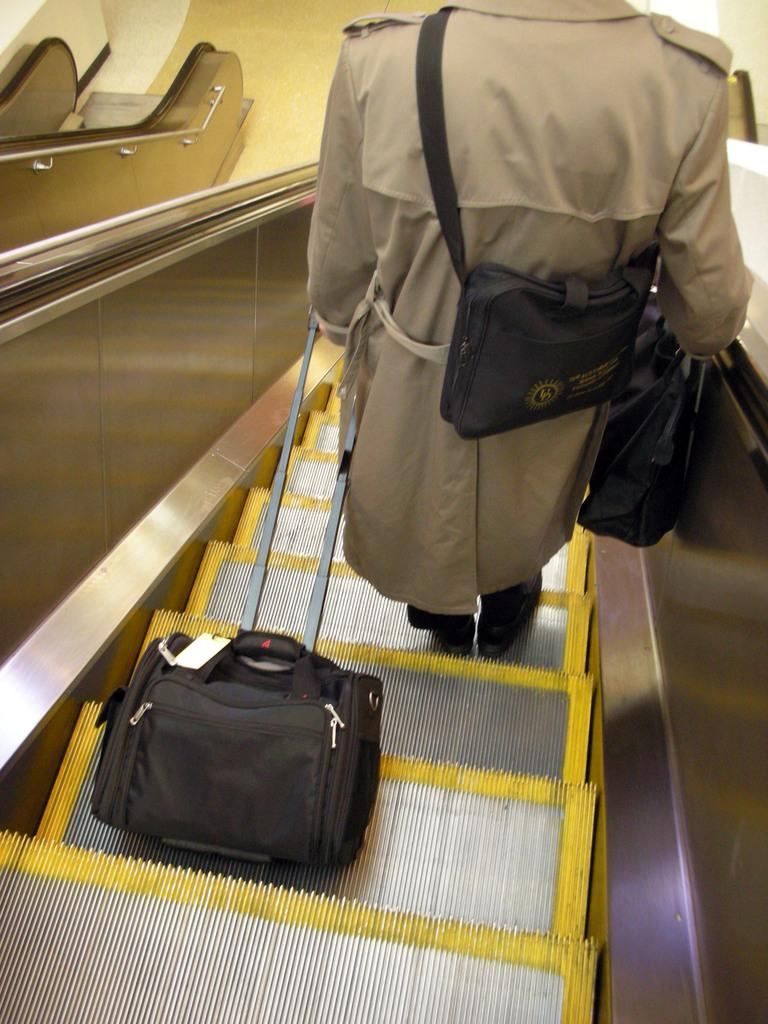What can be seen in the image? There is a person in the image. What is the person wearing? The person is wearing a jacket. What is the person holding in their hand? The person is holding a luggage bag in their hand. What else is the person holding? The person is also holding a bag. Where is the person standing? The person is standing on an escalator. What floor is the escalator on? The escalator is on a floor. What type of brass instrument is the person playing in the image? There is no brass instrument present in the image. What is the person using to cover their luggage bag in the image? The person is not using anything to cover their luggage bag in the image. 